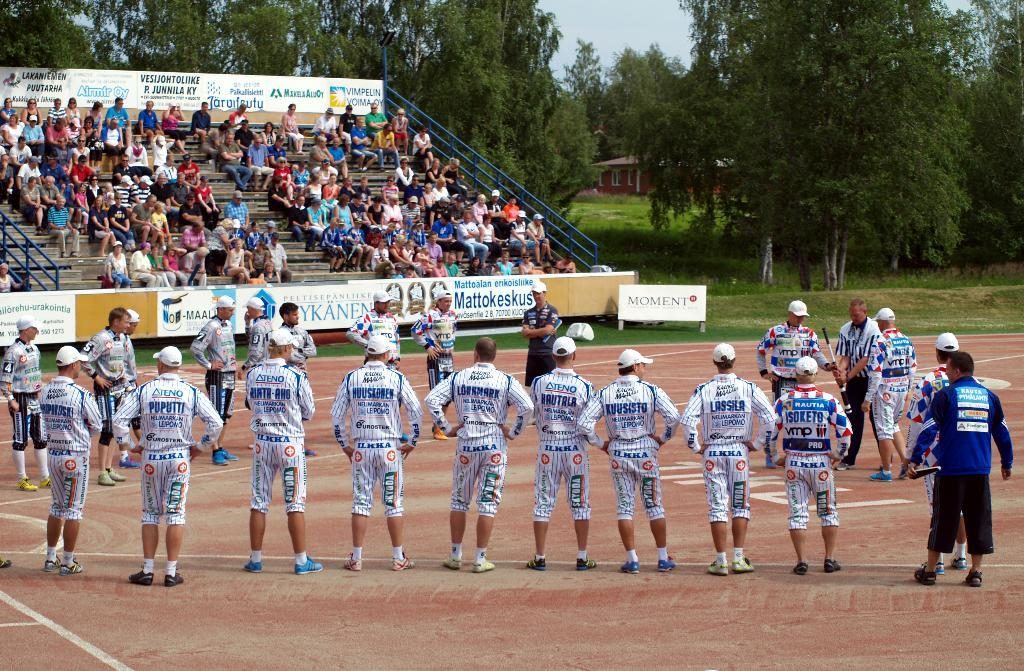Provide a one-sentence caption for the provided image. a person with pants that say Ilkha on them. 